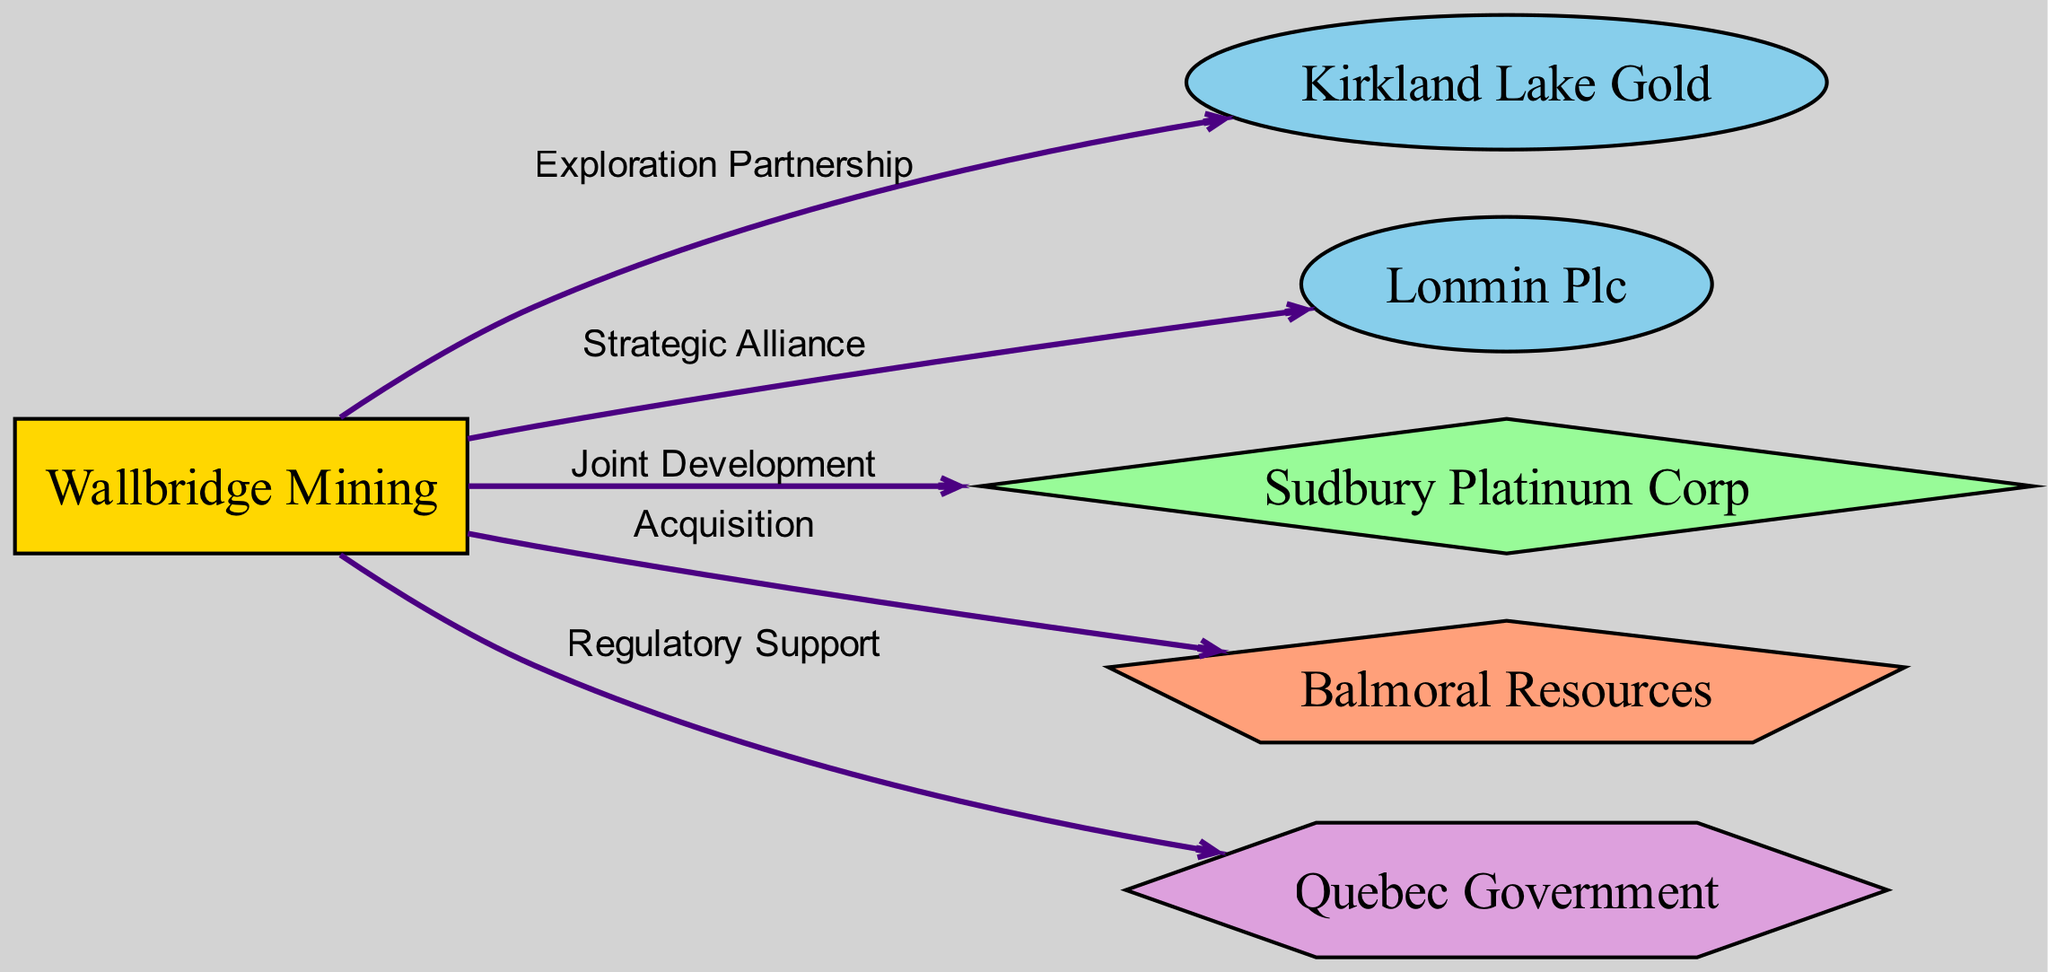What is the total number of nodes in the diagram? Counting the nodes listed in the data, we find there are six nodes: Wallbridge Mining, Kirkland Lake Gold, Lonmin Plc, Sudbury Platinum Corp, Balmoral Resources, and Quebec Government.
Answer: 6 What type of partnership exists between Wallbridge Mining and Kirkland Lake Gold? The edge between Wallbridge Mining and Kirkland Lake Gold is labeled "Exploration Partnership," indicating the nature of their relationship.
Answer: Exploration Partnership Who is the regulatory partner for Wallbridge Mining? The node representing the Quebec Government is connected to Wallbridge Mining, indicating its role as the regulator providing support to Wallbridge Mining.
Answer: Quebec Government How many types of relationships are represented in the diagram? The edges represent different types of relationships: Exploration Partnership, Strategic Alliance, Joint Development, Acquisition, and Regulatory Support. This totals five distinct types of relationships.
Answer: 5 Which company is a subsidiary of Wallbridge Mining? The edge that connects Wallbridge Mining to Balmoral Resources indicates that Balmoral Resources is a subsidiary of Wallbridge Mining.
Answer: Balmoral Resources What is the nature of the collaboration between Wallbridge Mining and Sudbury Platinum Corp? The relationship denoted by the edge between Wallbridge Mining and Sudbury Platinum Corp is labeled "Joint Development," describing the collaborative effort between the two entities.
Answer: Joint Development Which company is involved in a strategic alliance with Wallbridge Mining? The edge labeled "Strategic Alliance" connects Wallbridge Mining to Lonmin Plc, indicating their relationship.
Answer: Lonmin Plc What is the total number of edges in the diagram? By counting the edges from the data, we see that there are five connections: Wallbridge Mining to Kirkland Lake Gold, Wallbridge Mining to Lonmin Plc, Wallbridge Mining to Sudbury Platinum Corp, Wallbridge Mining to Balmoral Resources, and Wallbridge Mining to Quebec Government.
Answer: 5 What shape represents Wallbridge Mining in the diagram? Wallbridge Mining is classified as a company, and in the diagram, it is represented as a rectangle according to the defined node styles.
Answer: Rectangle 